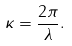<formula> <loc_0><loc_0><loc_500><loc_500>\kappa = \frac { 2 \pi } { \lambda } .</formula> 